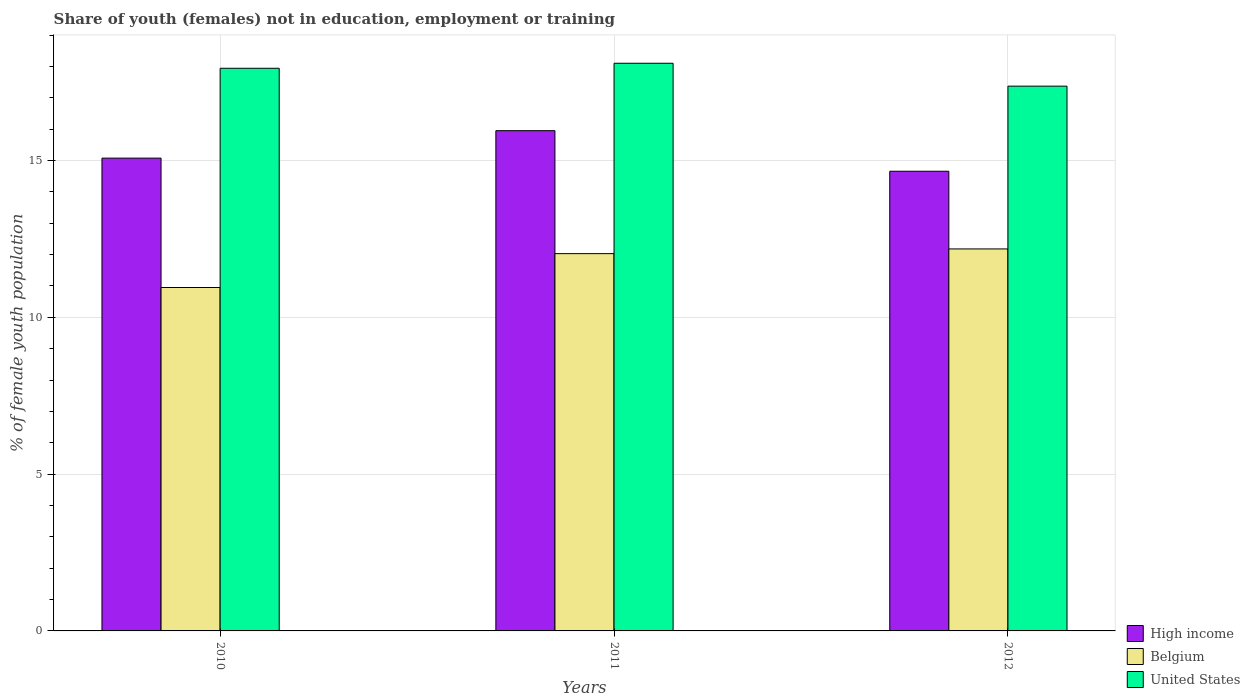Are the number of bars per tick equal to the number of legend labels?
Your response must be concise. Yes. Are the number of bars on each tick of the X-axis equal?
Provide a short and direct response. Yes. What is the label of the 2nd group of bars from the left?
Offer a terse response. 2011. In how many cases, is the number of bars for a given year not equal to the number of legend labels?
Your response must be concise. 0. What is the percentage of unemployed female population in in High income in 2012?
Ensure brevity in your answer.  14.66. Across all years, what is the maximum percentage of unemployed female population in in Belgium?
Provide a short and direct response. 12.18. Across all years, what is the minimum percentage of unemployed female population in in High income?
Keep it short and to the point. 14.66. In which year was the percentage of unemployed female population in in Belgium maximum?
Offer a terse response. 2012. In which year was the percentage of unemployed female population in in Belgium minimum?
Keep it short and to the point. 2010. What is the total percentage of unemployed female population in in United States in the graph?
Your answer should be very brief. 53.41. What is the difference between the percentage of unemployed female population in in United States in 2011 and that in 2012?
Keep it short and to the point. 0.73. What is the difference between the percentage of unemployed female population in in High income in 2011 and the percentage of unemployed female population in in United States in 2012?
Offer a very short reply. -1.42. What is the average percentage of unemployed female population in in Belgium per year?
Offer a terse response. 11.72. In the year 2012, what is the difference between the percentage of unemployed female population in in United States and percentage of unemployed female population in in Belgium?
Offer a very short reply. 5.19. In how many years, is the percentage of unemployed female population in in High income greater than 7 %?
Make the answer very short. 3. What is the ratio of the percentage of unemployed female population in in High income in 2011 to that in 2012?
Your response must be concise. 1.09. Is the percentage of unemployed female population in in High income in 2010 less than that in 2012?
Your answer should be very brief. No. What is the difference between the highest and the second highest percentage of unemployed female population in in United States?
Keep it short and to the point. 0.16. What is the difference between the highest and the lowest percentage of unemployed female population in in Belgium?
Keep it short and to the point. 1.23. Is the sum of the percentage of unemployed female population in in United States in 2011 and 2012 greater than the maximum percentage of unemployed female population in in High income across all years?
Your answer should be compact. Yes. What does the 1st bar from the left in 2011 represents?
Provide a succinct answer. High income. What does the 1st bar from the right in 2012 represents?
Ensure brevity in your answer.  United States. How many bars are there?
Provide a short and direct response. 9. What is the difference between two consecutive major ticks on the Y-axis?
Keep it short and to the point. 5. Are the values on the major ticks of Y-axis written in scientific E-notation?
Offer a terse response. No. Does the graph contain any zero values?
Give a very brief answer. No. Does the graph contain grids?
Give a very brief answer. Yes. How are the legend labels stacked?
Provide a short and direct response. Vertical. What is the title of the graph?
Your response must be concise. Share of youth (females) not in education, employment or training. What is the label or title of the X-axis?
Offer a very short reply. Years. What is the label or title of the Y-axis?
Ensure brevity in your answer.  % of female youth population. What is the % of female youth population of High income in 2010?
Offer a terse response. 15.07. What is the % of female youth population in Belgium in 2010?
Provide a succinct answer. 10.95. What is the % of female youth population in United States in 2010?
Your answer should be compact. 17.94. What is the % of female youth population in High income in 2011?
Offer a very short reply. 15.95. What is the % of female youth population of Belgium in 2011?
Your answer should be very brief. 12.03. What is the % of female youth population of United States in 2011?
Offer a terse response. 18.1. What is the % of female youth population of High income in 2012?
Your answer should be very brief. 14.66. What is the % of female youth population in Belgium in 2012?
Your response must be concise. 12.18. What is the % of female youth population of United States in 2012?
Your response must be concise. 17.37. Across all years, what is the maximum % of female youth population in High income?
Your answer should be very brief. 15.95. Across all years, what is the maximum % of female youth population in Belgium?
Offer a very short reply. 12.18. Across all years, what is the maximum % of female youth population in United States?
Make the answer very short. 18.1. Across all years, what is the minimum % of female youth population in High income?
Your answer should be compact. 14.66. Across all years, what is the minimum % of female youth population in Belgium?
Your answer should be compact. 10.95. Across all years, what is the minimum % of female youth population in United States?
Your response must be concise. 17.37. What is the total % of female youth population in High income in the graph?
Keep it short and to the point. 45.68. What is the total % of female youth population of Belgium in the graph?
Provide a succinct answer. 35.16. What is the total % of female youth population of United States in the graph?
Make the answer very short. 53.41. What is the difference between the % of female youth population of High income in 2010 and that in 2011?
Offer a very short reply. -0.88. What is the difference between the % of female youth population in Belgium in 2010 and that in 2011?
Offer a very short reply. -1.08. What is the difference between the % of female youth population of United States in 2010 and that in 2011?
Give a very brief answer. -0.16. What is the difference between the % of female youth population of High income in 2010 and that in 2012?
Your answer should be very brief. 0.42. What is the difference between the % of female youth population of Belgium in 2010 and that in 2012?
Ensure brevity in your answer.  -1.23. What is the difference between the % of female youth population of United States in 2010 and that in 2012?
Provide a succinct answer. 0.57. What is the difference between the % of female youth population of High income in 2011 and that in 2012?
Provide a short and direct response. 1.29. What is the difference between the % of female youth population in Belgium in 2011 and that in 2012?
Your answer should be compact. -0.15. What is the difference between the % of female youth population in United States in 2011 and that in 2012?
Your answer should be very brief. 0.73. What is the difference between the % of female youth population of High income in 2010 and the % of female youth population of Belgium in 2011?
Make the answer very short. 3.04. What is the difference between the % of female youth population of High income in 2010 and the % of female youth population of United States in 2011?
Your answer should be very brief. -3.03. What is the difference between the % of female youth population of Belgium in 2010 and the % of female youth population of United States in 2011?
Your answer should be compact. -7.15. What is the difference between the % of female youth population in High income in 2010 and the % of female youth population in Belgium in 2012?
Your response must be concise. 2.89. What is the difference between the % of female youth population of High income in 2010 and the % of female youth population of United States in 2012?
Offer a terse response. -2.3. What is the difference between the % of female youth population of Belgium in 2010 and the % of female youth population of United States in 2012?
Your answer should be compact. -6.42. What is the difference between the % of female youth population in High income in 2011 and the % of female youth population in Belgium in 2012?
Provide a succinct answer. 3.77. What is the difference between the % of female youth population of High income in 2011 and the % of female youth population of United States in 2012?
Your answer should be compact. -1.42. What is the difference between the % of female youth population in Belgium in 2011 and the % of female youth population in United States in 2012?
Give a very brief answer. -5.34. What is the average % of female youth population in High income per year?
Keep it short and to the point. 15.23. What is the average % of female youth population in Belgium per year?
Your response must be concise. 11.72. What is the average % of female youth population of United States per year?
Your answer should be compact. 17.8. In the year 2010, what is the difference between the % of female youth population of High income and % of female youth population of Belgium?
Provide a succinct answer. 4.12. In the year 2010, what is the difference between the % of female youth population of High income and % of female youth population of United States?
Your answer should be very brief. -2.87. In the year 2010, what is the difference between the % of female youth population in Belgium and % of female youth population in United States?
Give a very brief answer. -6.99. In the year 2011, what is the difference between the % of female youth population in High income and % of female youth population in Belgium?
Offer a terse response. 3.92. In the year 2011, what is the difference between the % of female youth population of High income and % of female youth population of United States?
Ensure brevity in your answer.  -2.15. In the year 2011, what is the difference between the % of female youth population of Belgium and % of female youth population of United States?
Keep it short and to the point. -6.07. In the year 2012, what is the difference between the % of female youth population of High income and % of female youth population of Belgium?
Your answer should be very brief. 2.48. In the year 2012, what is the difference between the % of female youth population in High income and % of female youth population in United States?
Keep it short and to the point. -2.71. In the year 2012, what is the difference between the % of female youth population of Belgium and % of female youth population of United States?
Offer a terse response. -5.19. What is the ratio of the % of female youth population in High income in 2010 to that in 2011?
Ensure brevity in your answer.  0.95. What is the ratio of the % of female youth population of Belgium in 2010 to that in 2011?
Make the answer very short. 0.91. What is the ratio of the % of female youth population in United States in 2010 to that in 2011?
Keep it short and to the point. 0.99. What is the ratio of the % of female youth population in High income in 2010 to that in 2012?
Provide a succinct answer. 1.03. What is the ratio of the % of female youth population in Belgium in 2010 to that in 2012?
Offer a terse response. 0.9. What is the ratio of the % of female youth population in United States in 2010 to that in 2012?
Offer a terse response. 1.03. What is the ratio of the % of female youth population in High income in 2011 to that in 2012?
Provide a succinct answer. 1.09. What is the ratio of the % of female youth population of Belgium in 2011 to that in 2012?
Offer a very short reply. 0.99. What is the ratio of the % of female youth population in United States in 2011 to that in 2012?
Offer a very short reply. 1.04. What is the difference between the highest and the second highest % of female youth population of High income?
Offer a terse response. 0.88. What is the difference between the highest and the second highest % of female youth population in United States?
Keep it short and to the point. 0.16. What is the difference between the highest and the lowest % of female youth population in High income?
Your response must be concise. 1.29. What is the difference between the highest and the lowest % of female youth population in Belgium?
Make the answer very short. 1.23. What is the difference between the highest and the lowest % of female youth population of United States?
Your answer should be compact. 0.73. 